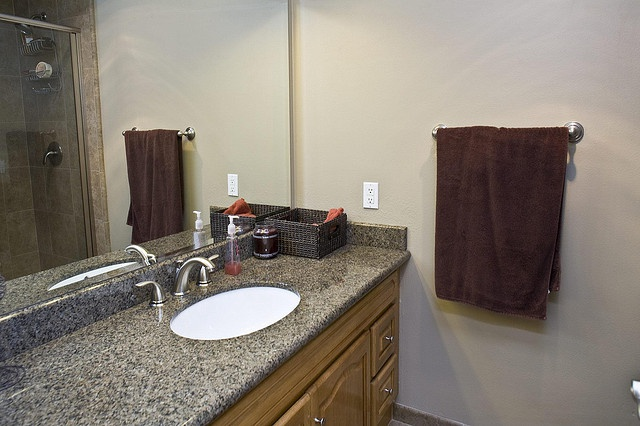Describe the objects in this image and their specific colors. I can see a sink in black, lavender, gray, and darkgray tones in this image. 